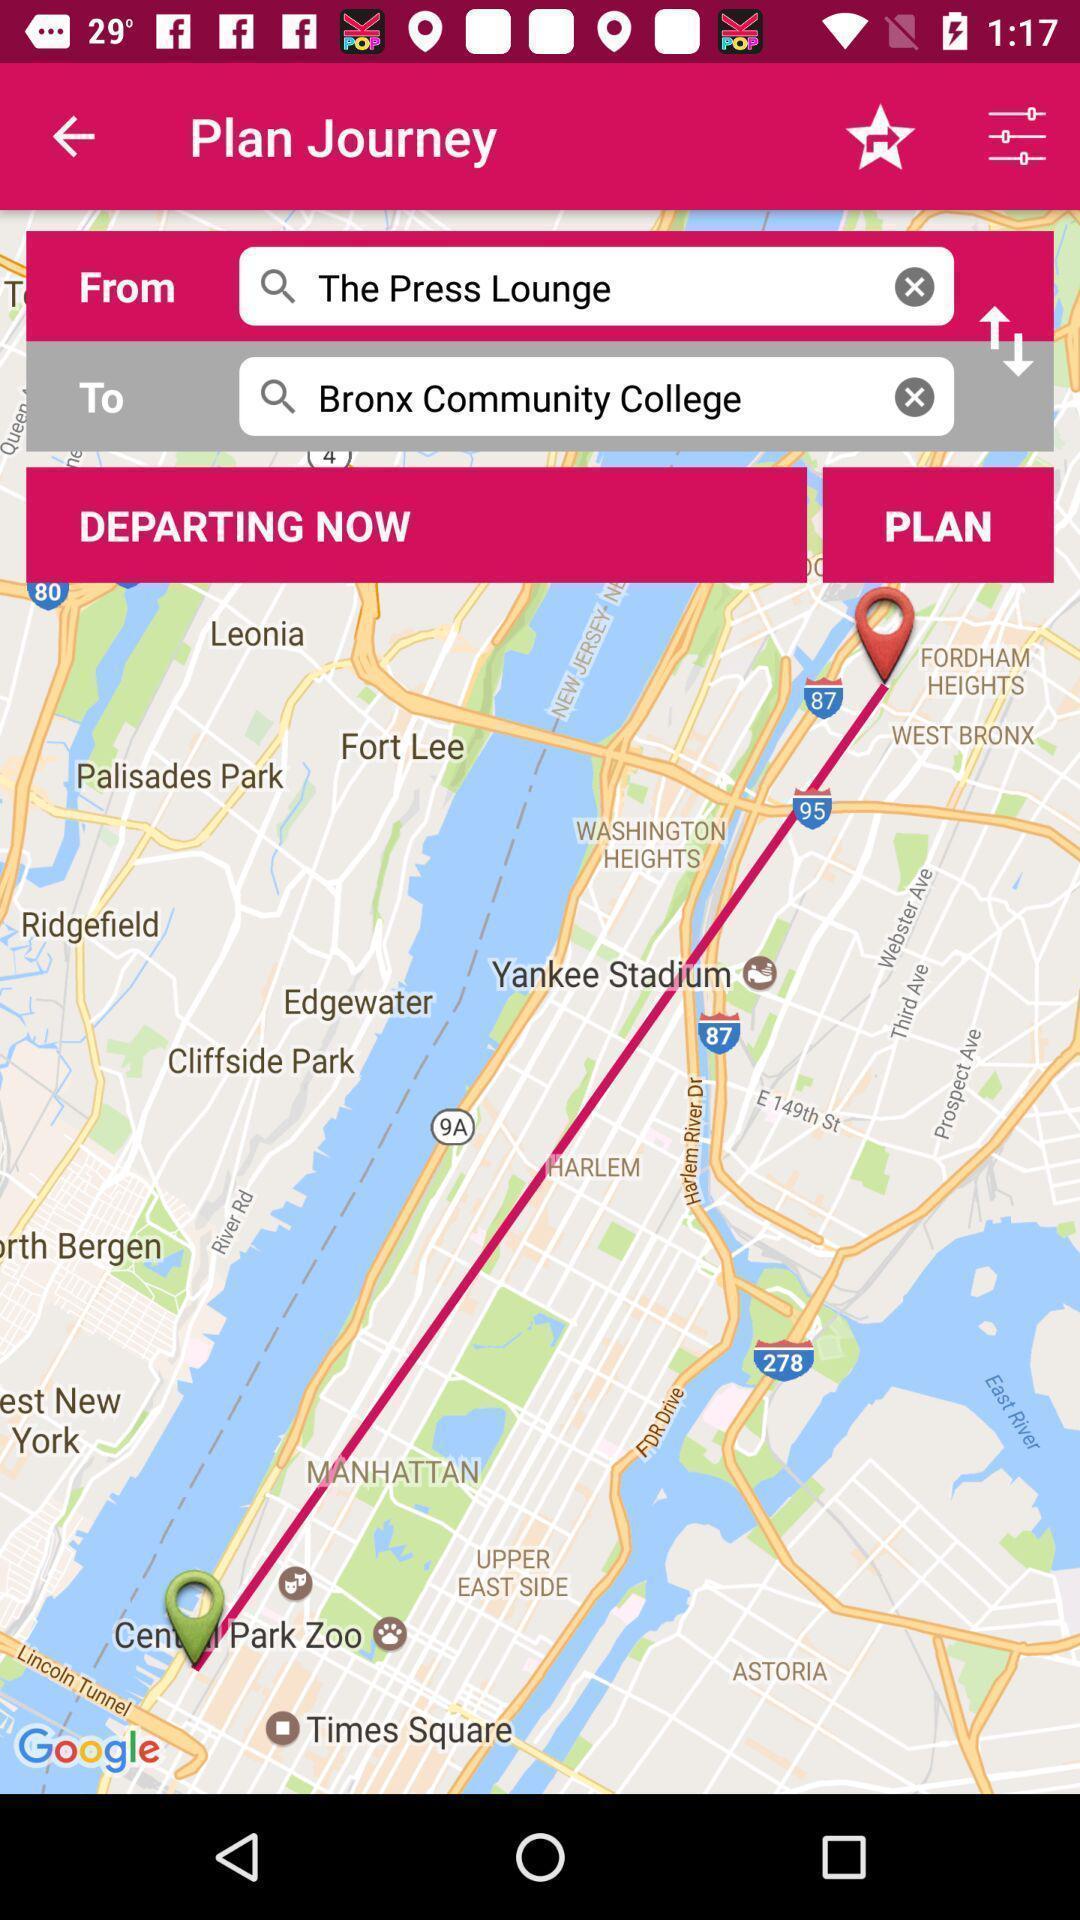Summarize the main components in this picture. Page that displaying gps application. 